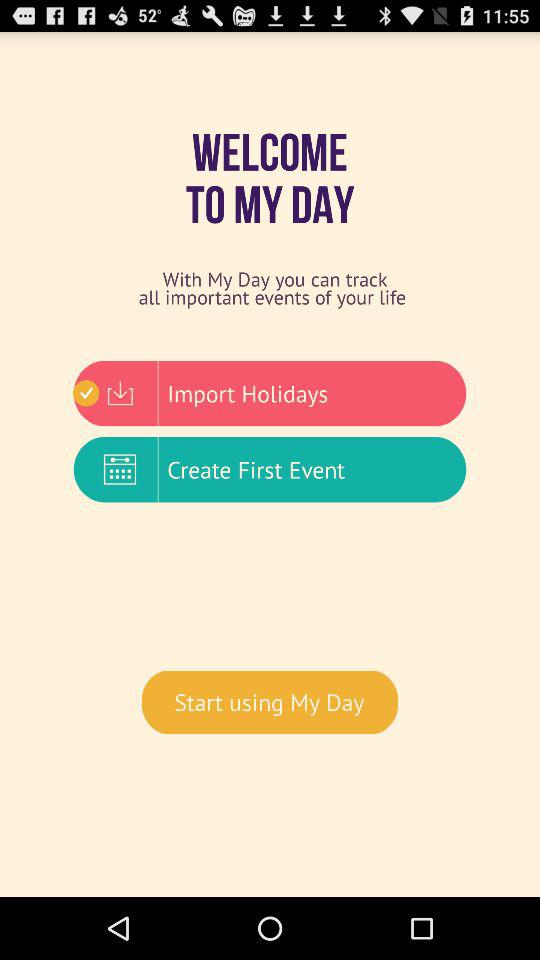What is the name of the application? The name of the application is "MY DAY". 